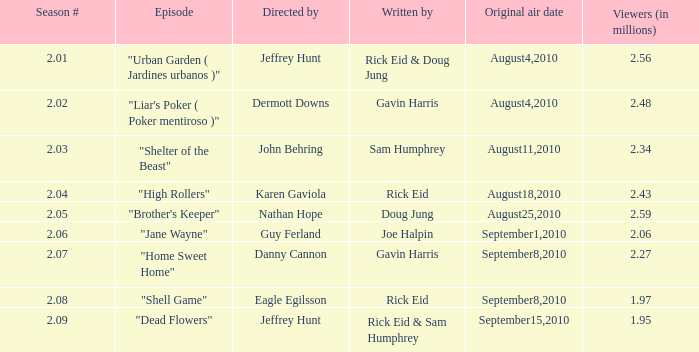08? 18.0. 